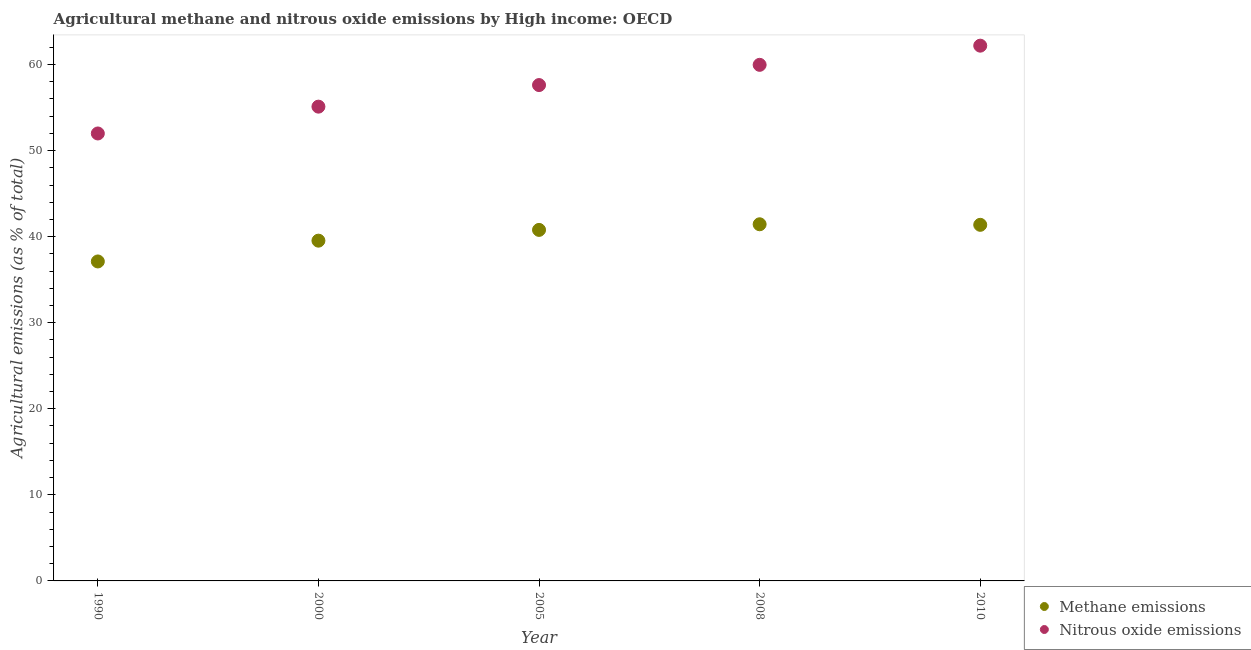How many different coloured dotlines are there?
Make the answer very short. 2. What is the amount of nitrous oxide emissions in 2010?
Provide a short and direct response. 62.19. Across all years, what is the maximum amount of methane emissions?
Offer a very short reply. 41.44. Across all years, what is the minimum amount of methane emissions?
Your answer should be compact. 37.12. What is the total amount of methane emissions in the graph?
Offer a terse response. 200.25. What is the difference between the amount of methane emissions in 1990 and that in 2010?
Your answer should be very brief. -4.26. What is the difference between the amount of nitrous oxide emissions in 2010 and the amount of methane emissions in 1990?
Your response must be concise. 25.07. What is the average amount of nitrous oxide emissions per year?
Offer a very short reply. 57.37. In the year 2000, what is the difference between the amount of methane emissions and amount of nitrous oxide emissions?
Make the answer very short. -15.57. What is the ratio of the amount of nitrous oxide emissions in 2000 to that in 2005?
Ensure brevity in your answer.  0.96. What is the difference between the highest and the second highest amount of nitrous oxide emissions?
Offer a very short reply. 2.23. What is the difference between the highest and the lowest amount of methane emissions?
Your response must be concise. 4.32. Is the amount of methane emissions strictly greater than the amount of nitrous oxide emissions over the years?
Provide a short and direct response. No. Is the amount of nitrous oxide emissions strictly less than the amount of methane emissions over the years?
Offer a very short reply. No. How many years are there in the graph?
Offer a terse response. 5. What is the difference between two consecutive major ticks on the Y-axis?
Make the answer very short. 10. Does the graph contain grids?
Offer a very short reply. No. Where does the legend appear in the graph?
Give a very brief answer. Bottom right. How many legend labels are there?
Ensure brevity in your answer.  2. What is the title of the graph?
Give a very brief answer. Agricultural methane and nitrous oxide emissions by High income: OECD. What is the label or title of the Y-axis?
Give a very brief answer. Agricultural emissions (as % of total). What is the Agricultural emissions (as % of total) in Methane emissions in 1990?
Offer a terse response. 37.12. What is the Agricultural emissions (as % of total) of Nitrous oxide emissions in 1990?
Your answer should be very brief. 51.99. What is the Agricultural emissions (as % of total) in Methane emissions in 2000?
Your response must be concise. 39.53. What is the Agricultural emissions (as % of total) of Nitrous oxide emissions in 2000?
Offer a terse response. 55.1. What is the Agricultural emissions (as % of total) of Methane emissions in 2005?
Your answer should be compact. 40.78. What is the Agricultural emissions (as % of total) in Nitrous oxide emissions in 2005?
Provide a short and direct response. 57.61. What is the Agricultural emissions (as % of total) in Methane emissions in 2008?
Provide a succinct answer. 41.44. What is the Agricultural emissions (as % of total) of Nitrous oxide emissions in 2008?
Your answer should be very brief. 59.96. What is the Agricultural emissions (as % of total) in Methane emissions in 2010?
Your response must be concise. 41.37. What is the Agricultural emissions (as % of total) in Nitrous oxide emissions in 2010?
Ensure brevity in your answer.  62.19. Across all years, what is the maximum Agricultural emissions (as % of total) of Methane emissions?
Give a very brief answer. 41.44. Across all years, what is the maximum Agricultural emissions (as % of total) of Nitrous oxide emissions?
Your answer should be compact. 62.19. Across all years, what is the minimum Agricultural emissions (as % of total) in Methane emissions?
Offer a terse response. 37.12. Across all years, what is the minimum Agricultural emissions (as % of total) of Nitrous oxide emissions?
Your answer should be compact. 51.99. What is the total Agricultural emissions (as % of total) of Methane emissions in the graph?
Provide a succinct answer. 200.25. What is the total Agricultural emissions (as % of total) of Nitrous oxide emissions in the graph?
Offer a very short reply. 286.86. What is the difference between the Agricultural emissions (as % of total) in Methane emissions in 1990 and that in 2000?
Ensure brevity in your answer.  -2.42. What is the difference between the Agricultural emissions (as % of total) of Nitrous oxide emissions in 1990 and that in 2000?
Give a very brief answer. -3.12. What is the difference between the Agricultural emissions (as % of total) of Methane emissions in 1990 and that in 2005?
Provide a short and direct response. -3.67. What is the difference between the Agricultural emissions (as % of total) in Nitrous oxide emissions in 1990 and that in 2005?
Keep it short and to the point. -5.62. What is the difference between the Agricultural emissions (as % of total) in Methane emissions in 1990 and that in 2008?
Your answer should be very brief. -4.32. What is the difference between the Agricultural emissions (as % of total) of Nitrous oxide emissions in 1990 and that in 2008?
Give a very brief answer. -7.97. What is the difference between the Agricultural emissions (as % of total) of Methane emissions in 1990 and that in 2010?
Ensure brevity in your answer.  -4.26. What is the difference between the Agricultural emissions (as % of total) in Nitrous oxide emissions in 1990 and that in 2010?
Ensure brevity in your answer.  -10.2. What is the difference between the Agricultural emissions (as % of total) of Methane emissions in 2000 and that in 2005?
Ensure brevity in your answer.  -1.25. What is the difference between the Agricultural emissions (as % of total) of Nitrous oxide emissions in 2000 and that in 2005?
Provide a succinct answer. -2.51. What is the difference between the Agricultural emissions (as % of total) in Methane emissions in 2000 and that in 2008?
Make the answer very short. -1.9. What is the difference between the Agricultural emissions (as % of total) of Nitrous oxide emissions in 2000 and that in 2008?
Give a very brief answer. -4.86. What is the difference between the Agricultural emissions (as % of total) of Methane emissions in 2000 and that in 2010?
Your answer should be very brief. -1.84. What is the difference between the Agricultural emissions (as % of total) in Nitrous oxide emissions in 2000 and that in 2010?
Offer a terse response. -7.09. What is the difference between the Agricultural emissions (as % of total) of Methane emissions in 2005 and that in 2008?
Make the answer very short. -0.65. What is the difference between the Agricultural emissions (as % of total) in Nitrous oxide emissions in 2005 and that in 2008?
Offer a terse response. -2.35. What is the difference between the Agricultural emissions (as % of total) of Methane emissions in 2005 and that in 2010?
Provide a short and direct response. -0.59. What is the difference between the Agricultural emissions (as % of total) in Nitrous oxide emissions in 2005 and that in 2010?
Offer a terse response. -4.58. What is the difference between the Agricultural emissions (as % of total) in Methane emissions in 2008 and that in 2010?
Provide a short and direct response. 0.06. What is the difference between the Agricultural emissions (as % of total) in Nitrous oxide emissions in 2008 and that in 2010?
Make the answer very short. -2.23. What is the difference between the Agricultural emissions (as % of total) of Methane emissions in 1990 and the Agricultural emissions (as % of total) of Nitrous oxide emissions in 2000?
Ensure brevity in your answer.  -17.99. What is the difference between the Agricultural emissions (as % of total) of Methane emissions in 1990 and the Agricultural emissions (as % of total) of Nitrous oxide emissions in 2005?
Provide a short and direct response. -20.49. What is the difference between the Agricultural emissions (as % of total) of Methane emissions in 1990 and the Agricultural emissions (as % of total) of Nitrous oxide emissions in 2008?
Provide a succinct answer. -22.84. What is the difference between the Agricultural emissions (as % of total) of Methane emissions in 1990 and the Agricultural emissions (as % of total) of Nitrous oxide emissions in 2010?
Give a very brief answer. -25.07. What is the difference between the Agricultural emissions (as % of total) of Methane emissions in 2000 and the Agricultural emissions (as % of total) of Nitrous oxide emissions in 2005?
Offer a terse response. -18.08. What is the difference between the Agricultural emissions (as % of total) of Methane emissions in 2000 and the Agricultural emissions (as % of total) of Nitrous oxide emissions in 2008?
Your answer should be very brief. -20.43. What is the difference between the Agricultural emissions (as % of total) of Methane emissions in 2000 and the Agricultural emissions (as % of total) of Nitrous oxide emissions in 2010?
Provide a succinct answer. -22.66. What is the difference between the Agricultural emissions (as % of total) of Methane emissions in 2005 and the Agricultural emissions (as % of total) of Nitrous oxide emissions in 2008?
Provide a succinct answer. -19.18. What is the difference between the Agricultural emissions (as % of total) of Methane emissions in 2005 and the Agricultural emissions (as % of total) of Nitrous oxide emissions in 2010?
Ensure brevity in your answer.  -21.41. What is the difference between the Agricultural emissions (as % of total) in Methane emissions in 2008 and the Agricultural emissions (as % of total) in Nitrous oxide emissions in 2010?
Keep it short and to the point. -20.75. What is the average Agricultural emissions (as % of total) of Methane emissions per year?
Your answer should be compact. 40.05. What is the average Agricultural emissions (as % of total) in Nitrous oxide emissions per year?
Give a very brief answer. 57.37. In the year 1990, what is the difference between the Agricultural emissions (as % of total) in Methane emissions and Agricultural emissions (as % of total) in Nitrous oxide emissions?
Offer a very short reply. -14.87. In the year 2000, what is the difference between the Agricultural emissions (as % of total) in Methane emissions and Agricultural emissions (as % of total) in Nitrous oxide emissions?
Keep it short and to the point. -15.57. In the year 2005, what is the difference between the Agricultural emissions (as % of total) in Methane emissions and Agricultural emissions (as % of total) in Nitrous oxide emissions?
Give a very brief answer. -16.83. In the year 2008, what is the difference between the Agricultural emissions (as % of total) in Methane emissions and Agricultural emissions (as % of total) in Nitrous oxide emissions?
Give a very brief answer. -18.52. In the year 2010, what is the difference between the Agricultural emissions (as % of total) of Methane emissions and Agricultural emissions (as % of total) of Nitrous oxide emissions?
Your answer should be compact. -20.82. What is the ratio of the Agricultural emissions (as % of total) in Methane emissions in 1990 to that in 2000?
Your answer should be compact. 0.94. What is the ratio of the Agricultural emissions (as % of total) in Nitrous oxide emissions in 1990 to that in 2000?
Provide a short and direct response. 0.94. What is the ratio of the Agricultural emissions (as % of total) of Methane emissions in 1990 to that in 2005?
Offer a very short reply. 0.91. What is the ratio of the Agricultural emissions (as % of total) of Nitrous oxide emissions in 1990 to that in 2005?
Keep it short and to the point. 0.9. What is the ratio of the Agricultural emissions (as % of total) of Methane emissions in 1990 to that in 2008?
Provide a succinct answer. 0.9. What is the ratio of the Agricultural emissions (as % of total) in Nitrous oxide emissions in 1990 to that in 2008?
Provide a short and direct response. 0.87. What is the ratio of the Agricultural emissions (as % of total) in Methane emissions in 1990 to that in 2010?
Ensure brevity in your answer.  0.9. What is the ratio of the Agricultural emissions (as % of total) of Nitrous oxide emissions in 1990 to that in 2010?
Provide a short and direct response. 0.84. What is the ratio of the Agricultural emissions (as % of total) of Methane emissions in 2000 to that in 2005?
Your answer should be very brief. 0.97. What is the ratio of the Agricultural emissions (as % of total) of Nitrous oxide emissions in 2000 to that in 2005?
Your response must be concise. 0.96. What is the ratio of the Agricultural emissions (as % of total) of Methane emissions in 2000 to that in 2008?
Your answer should be compact. 0.95. What is the ratio of the Agricultural emissions (as % of total) of Nitrous oxide emissions in 2000 to that in 2008?
Your response must be concise. 0.92. What is the ratio of the Agricultural emissions (as % of total) in Methane emissions in 2000 to that in 2010?
Keep it short and to the point. 0.96. What is the ratio of the Agricultural emissions (as % of total) of Nitrous oxide emissions in 2000 to that in 2010?
Offer a terse response. 0.89. What is the ratio of the Agricultural emissions (as % of total) in Methane emissions in 2005 to that in 2008?
Ensure brevity in your answer.  0.98. What is the ratio of the Agricultural emissions (as % of total) in Nitrous oxide emissions in 2005 to that in 2008?
Provide a succinct answer. 0.96. What is the ratio of the Agricultural emissions (as % of total) of Methane emissions in 2005 to that in 2010?
Give a very brief answer. 0.99. What is the ratio of the Agricultural emissions (as % of total) in Nitrous oxide emissions in 2005 to that in 2010?
Provide a succinct answer. 0.93. What is the ratio of the Agricultural emissions (as % of total) of Nitrous oxide emissions in 2008 to that in 2010?
Make the answer very short. 0.96. What is the difference between the highest and the second highest Agricultural emissions (as % of total) in Methane emissions?
Keep it short and to the point. 0.06. What is the difference between the highest and the second highest Agricultural emissions (as % of total) of Nitrous oxide emissions?
Provide a short and direct response. 2.23. What is the difference between the highest and the lowest Agricultural emissions (as % of total) of Methane emissions?
Offer a terse response. 4.32. What is the difference between the highest and the lowest Agricultural emissions (as % of total) of Nitrous oxide emissions?
Ensure brevity in your answer.  10.2. 